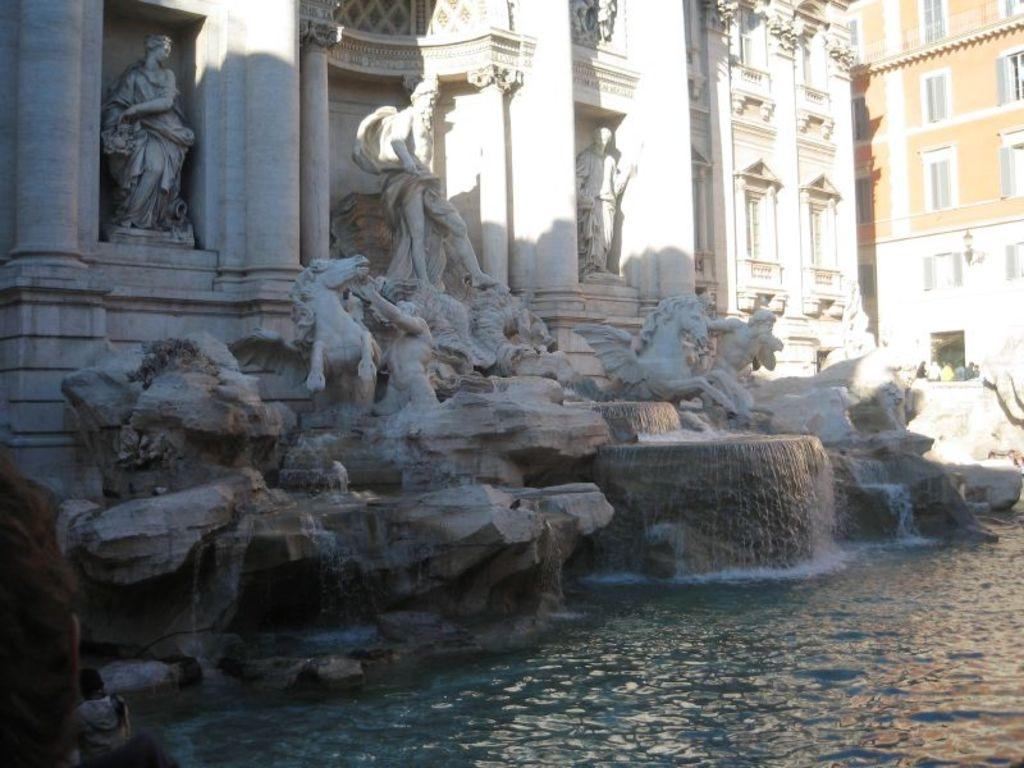What type of structures can be seen in the image? There are buildings in the image. What is located at the bottom of the image? There are sculptures at the bottom of the image. What feature is present in the image that involves water? There is a fountain in the image. Can you describe the water in the image? There is water visible in the image. Are there any living beings in the image? Yes, there are people in the image. What type of shoes are the people wearing in the image? There is no information about shoes in the image, as the focus is on the buildings, sculptures, fountain, water, and people. What type of drug can be seen in the image? There is no drug present in the image. 